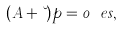Convert formula to latex. <formula><loc_0><loc_0><loc_500><loc_500>( A + \lambda ) p = 0 \ e s ,</formula> 